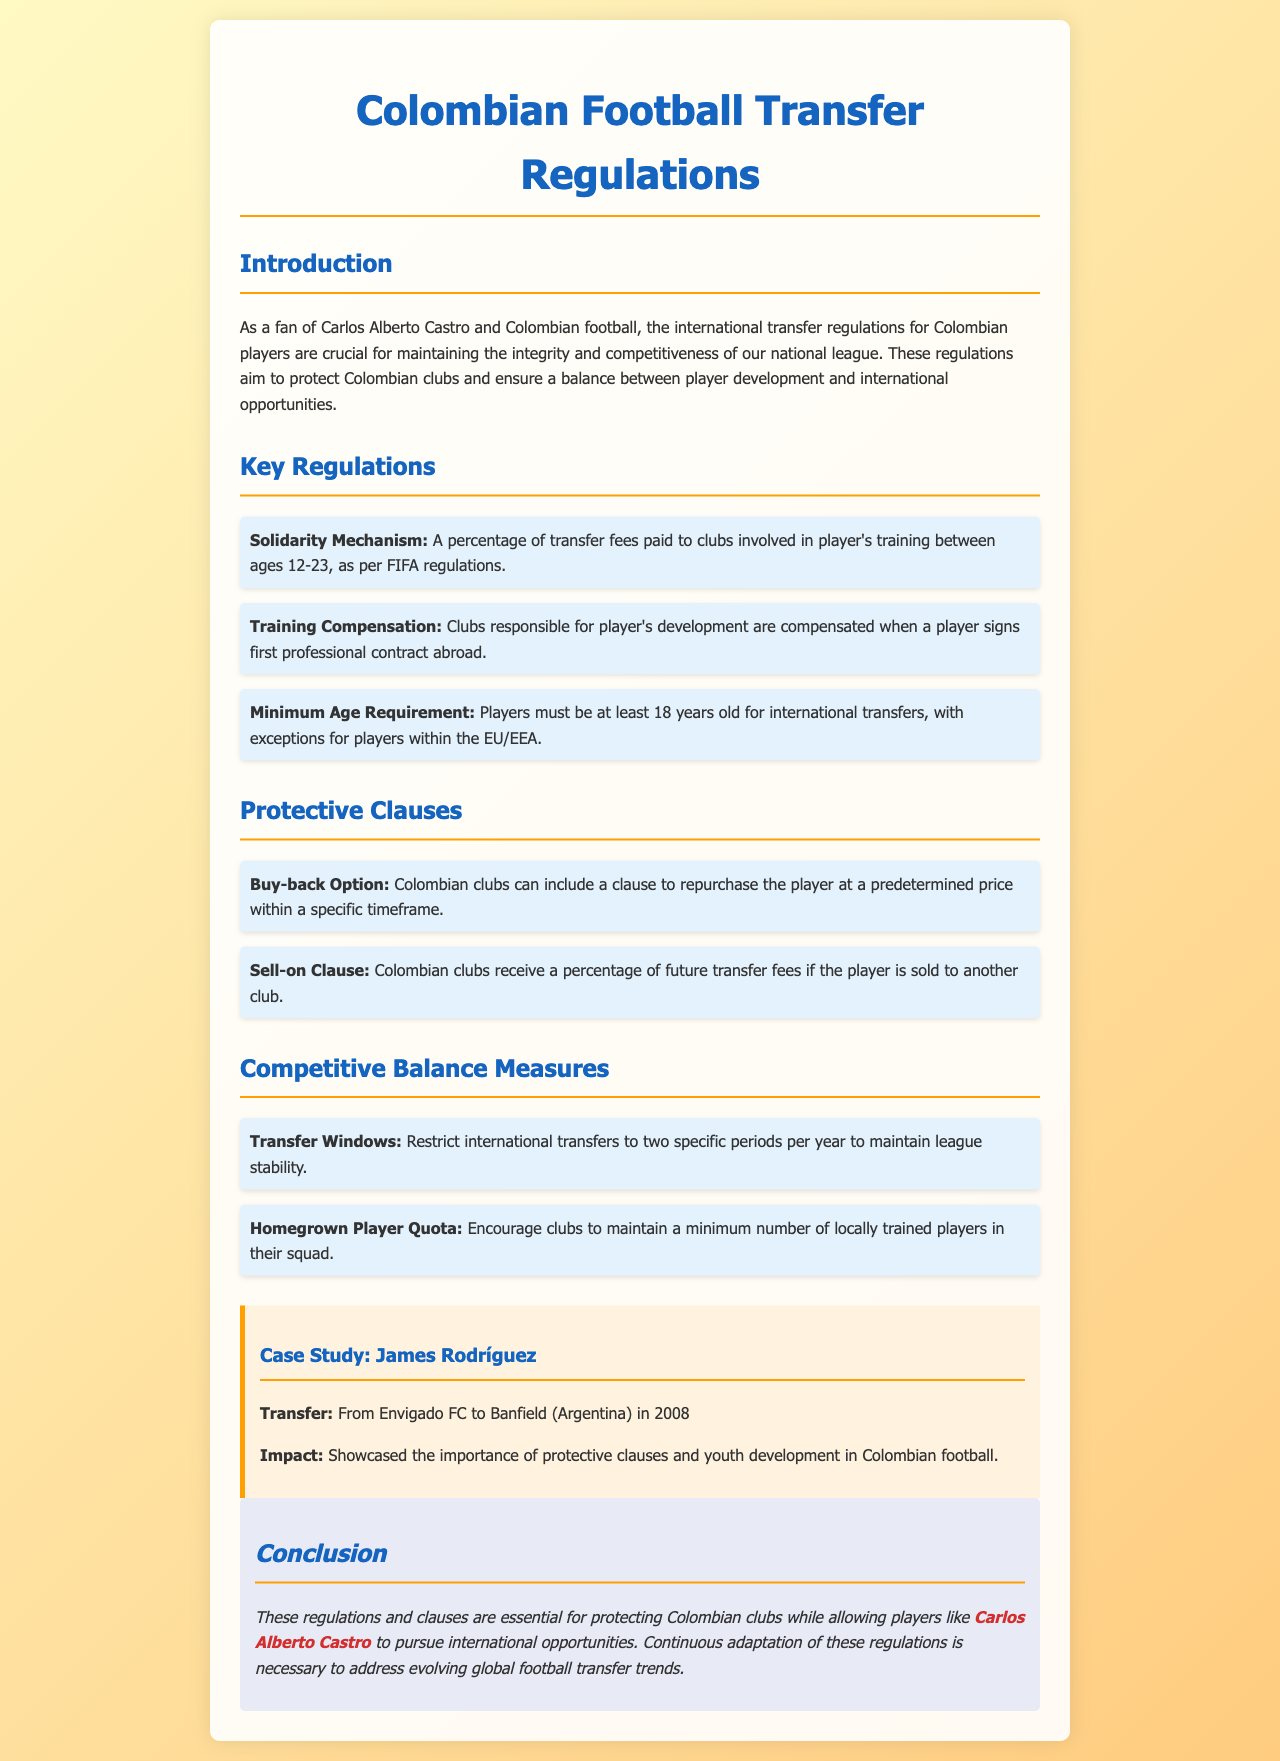What is the title of the document? The title of the document is located at the top of the rendered page.
Answer: Colombian Football Transfer Regulations What is the age minimum for international transfers? The document specifies the age requirement for international transfers.
Answer: 18 years What compensation do clubs receive for training players? The document outlines a specific compensation mechanism for clubs involved in a player’s development.
Answer: Training Compensation What clause allows repurchase of a player? The document mentions a specific option for clubs regarding player transfers.
Answer: Buy-back Option Which player is mentioned in the case study? The case study highlights a specific player related to transfers in Colombian football.
Answer: James Rodríguez What mechanism protects clubs during player transfers? The document describes mechanisms intended to safeguard clubs during international player movements.
Answer: Solidarity Mechanism How many transfer windows are specified annually? The document indicates the number of specific periods during which transfers are restricted.
Answer: Two What is encouraged through the homegrown player quota? The document discusses a specific quota aimed at promoting player development within clubs.
Answer: Locally trained players What is the purpose of the competitive balance measures? The document explains the rationale behind maintaining balance in the league amidst player transfers.
Answer: League stability 